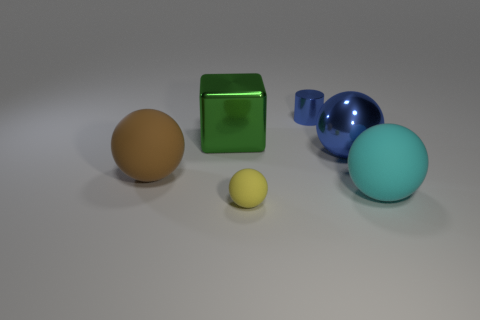Subtract 1 spheres. How many spheres are left? 3 Add 1 tiny brown spheres. How many objects exist? 7 Subtract all blocks. How many objects are left? 5 Subtract all brown spheres. Subtract all rubber spheres. How many objects are left? 2 Add 5 big rubber balls. How many big rubber balls are left? 7 Add 3 large green things. How many large green things exist? 4 Subtract 0 purple cubes. How many objects are left? 6 